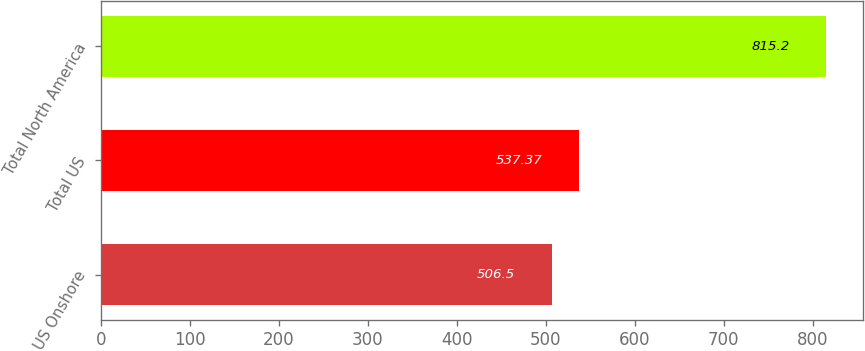<chart> <loc_0><loc_0><loc_500><loc_500><bar_chart><fcel>US Onshore<fcel>Total US<fcel>Total North America<nl><fcel>506.5<fcel>537.37<fcel>815.2<nl></chart> 